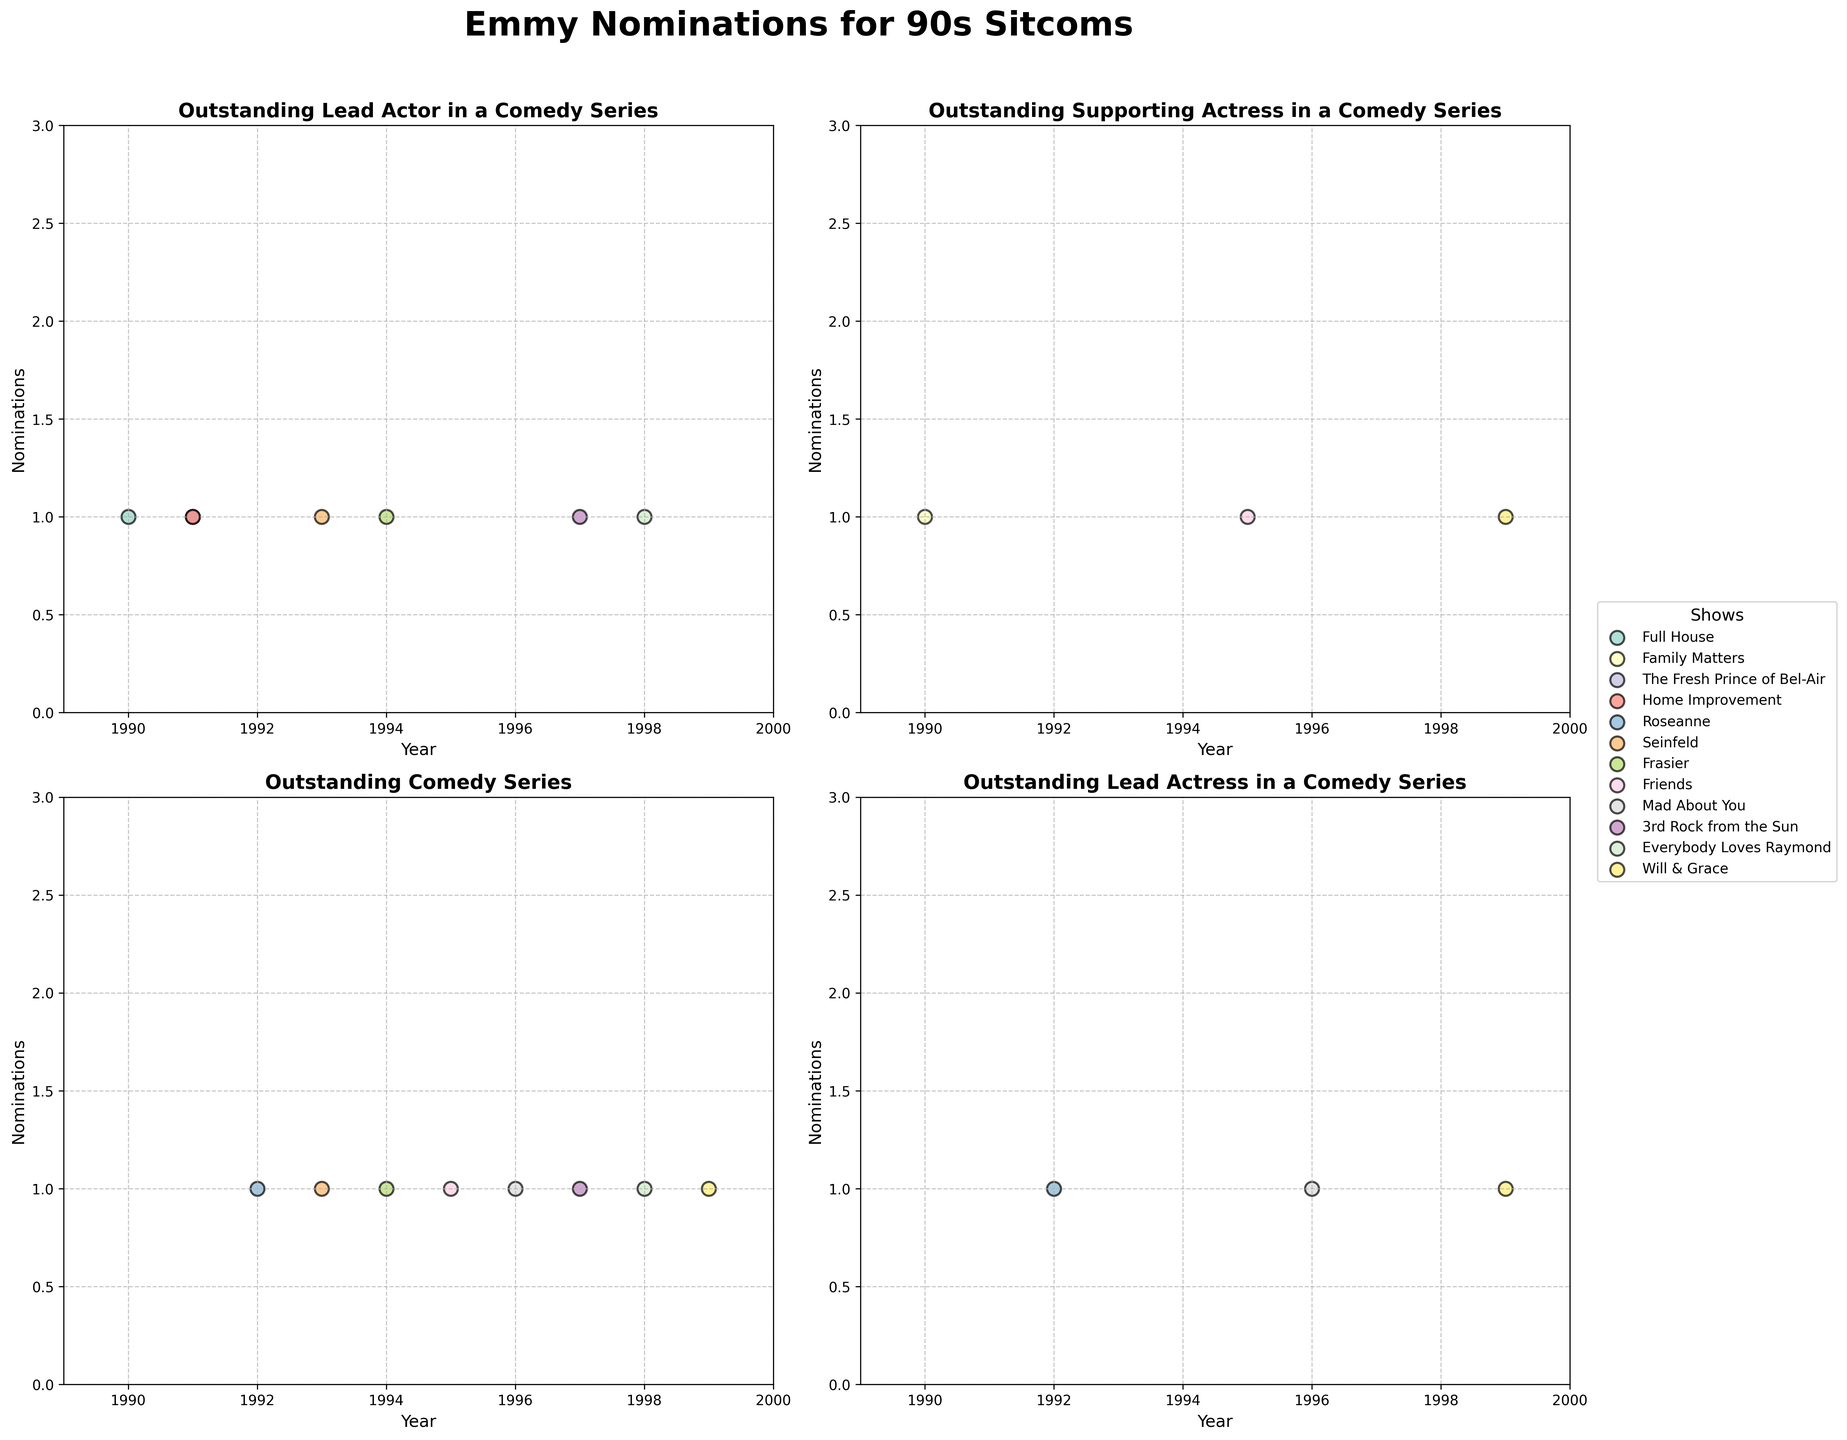Which show received nominations for the "Outstanding Lead Actress in a Comedy Series" category in the 1990s? We need to look for dots in the subplot titled "Outstanding Lead Actress in a Comedy Series" and check the labels for the shows that received nominations. Based on the figure, "Roseanne," "Mad About You," and "Will & Grace" received nominations very clearly.
Answer: "Roseanne," "Mad About You," and "Will & Grace" Between 1993 and 1994, which show had more nominations for the "Outstanding Lead Actor in a Comedy Series" category? Observe the subplot titled "Outstanding Lead Actor in a Comedy Series" and compare the number of dots for the years 1993 and 1994. "Seinfeld" received 1 nomination in 1993, while "Frasier" received 1 nomination in 1994.
Answer: It's a tie; both "Seinfeld" and "Frasier" had 1 nomination each Which show appears most frequently in the subplot for "Outstanding Comedy Series"? Check the subplot for the frequency of different shows. By counting the occurrences, "Will & Grace" appears most frequently in winning nominations.
Answer: "Will & Grace" How many total nominations did "Frasier" receive for "Outstanding Supporting Actor in a Comedy Series"? Look into the subplot titled "Outstanding Supporting Actor in a Comedy Series." Count the number of dots attributable to "Frasier."
Answer: 2 nominations Which show had nominations in both the "Outstanding Comedy Series" and "Outstanding Lead Actress in a Comedy Series" categories in 1999? Identify the points in both relevant subplots for the year 1999 and check if any show matches in both categories. "Will & Grace" received nominations in both categories in 1999.
Answer: "Will & Grace" 